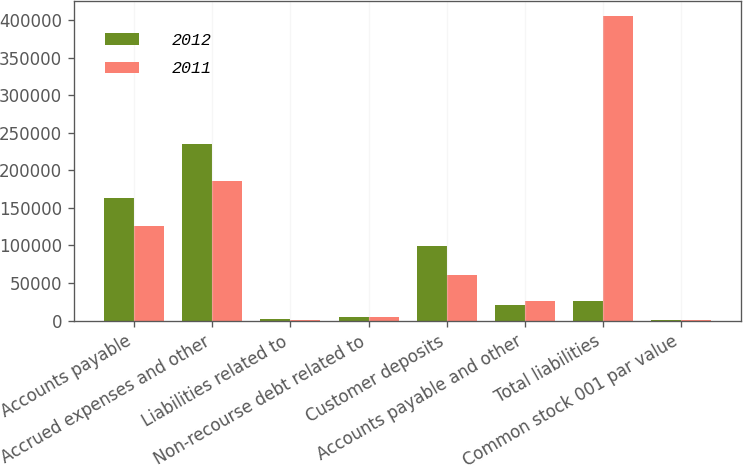Convert chart to OTSL. <chart><loc_0><loc_0><loc_500><loc_500><stacked_bar_chart><ecel><fcel>Accounts payable<fcel>Accrued expenses and other<fcel>Liabilities related to<fcel>Non-recourse debt related to<fcel>Customer deposits<fcel>Accounts payable and other<fcel>Total liabilities<fcel>Common stock 001 par value<nl><fcel>2012<fcel>163446<fcel>234804<fcel>2180<fcel>4574<fcel>99687<fcel>20686<fcel>26395<fcel>206<nl><fcel>2011<fcel>125649<fcel>185423<fcel>1013<fcel>4983<fcel>61223<fcel>26395<fcel>404686<fcel>206<nl></chart> 